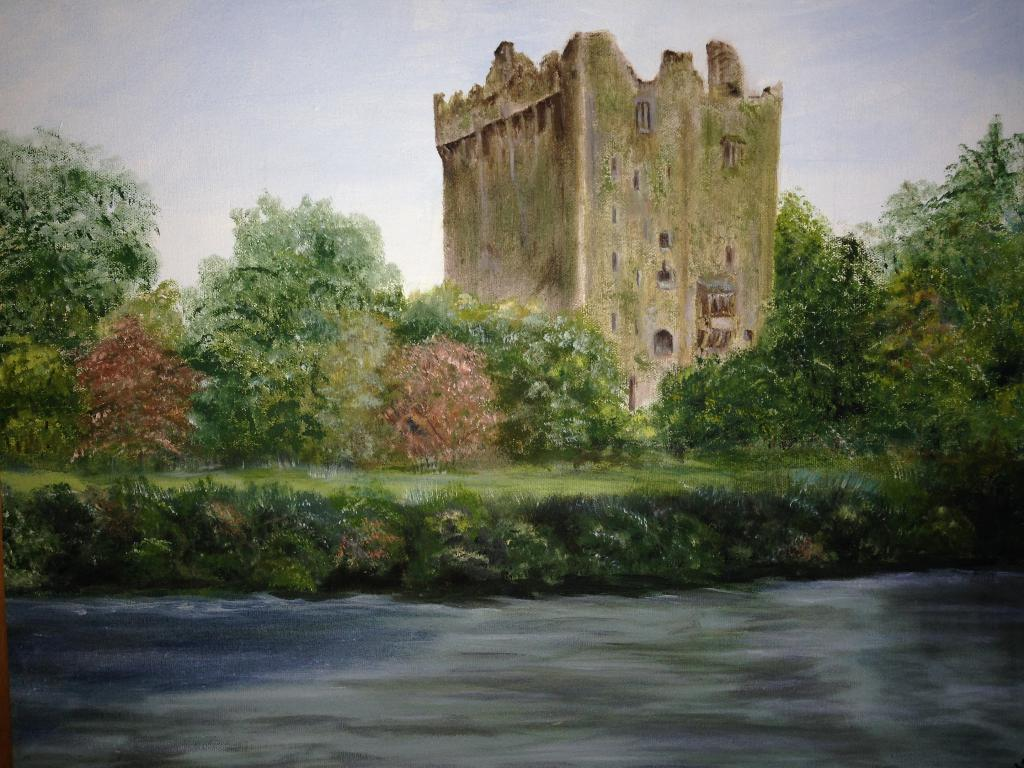What type of living organisms can be seen in the image? Plants can be seen in the image. What structure is present in the image? There is a tower in the image. What is the condition of the sky in the image? The sky is cloudy in the image. Can you tell me how many bubbles are floating around the tower in the image? There are no bubbles present in the image. Is there a spy observing the plants in the image? There is no indication of a spy or any person in the image. 